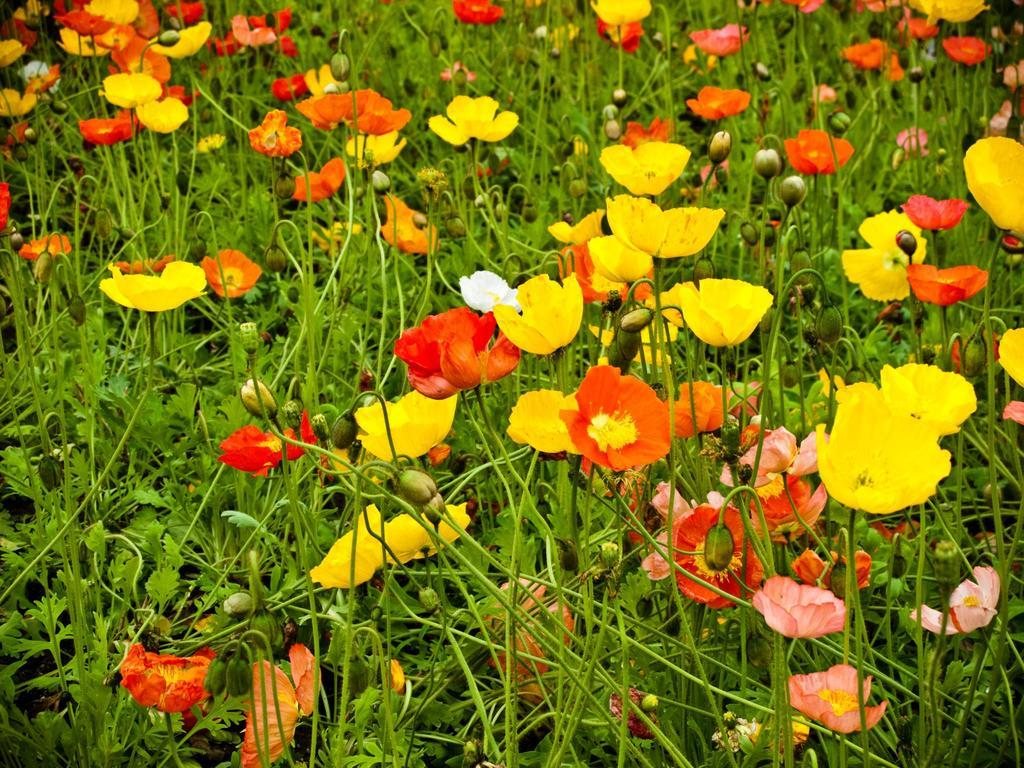What type of plants are visible in the image? There are flower plants in the image. Can you describe the appearance of the flower plants? The flower plants have colorful blooms and green foliage. What might be the purpose of these flower plants? The flower plants could be used for decoration or to attract pollinators. How many sheep can be seen grazing on the flower plants in the image? There are no sheep present in the image; it only features flower plants. 